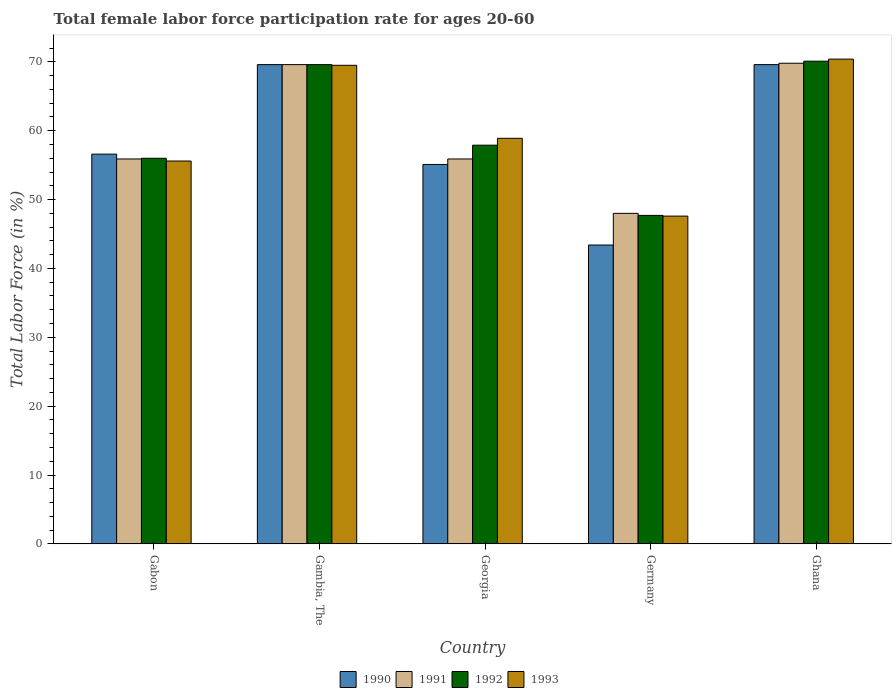How many groups of bars are there?
Provide a short and direct response. 5. Are the number of bars per tick equal to the number of legend labels?
Offer a very short reply. Yes. Are the number of bars on each tick of the X-axis equal?
Provide a succinct answer. Yes. How many bars are there on the 2nd tick from the right?
Keep it short and to the point. 4. What is the label of the 1st group of bars from the left?
Keep it short and to the point. Gabon. What is the female labor force participation rate in 1991 in Georgia?
Provide a short and direct response. 55.9. Across all countries, what is the maximum female labor force participation rate in 1990?
Provide a short and direct response. 69.6. Across all countries, what is the minimum female labor force participation rate in 1991?
Your response must be concise. 48. In which country was the female labor force participation rate in 1993 maximum?
Your answer should be compact. Ghana. In which country was the female labor force participation rate in 1993 minimum?
Offer a very short reply. Germany. What is the total female labor force participation rate in 1993 in the graph?
Offer a terse response. 302. What is the difference between the female labor force participation rate in 1992 in Gabon and that in Germany?
Ensure brevity in your answer.  8.3. What is the difference between the female labor force participation rate in 1993 in Gambia, The and the female labor force participation rate in 1992 in Georgia?
Ensure brevity in your answer.  11.6. What is the average female labor force participation rate in 1990 per country?
Provide a succinct answer. 58.86. What is the difference between the female labor force participation rate of/in 1991 and female labor force participation rate of/in 1993 in Gambia, The?
Your response must be concise. 0.1. What is the ratio of the female labor force participation rate in 1993 in Gambia, The to that in Germany?
Offer a very short reply. 1.46. Is the female labor force participation rate in 1993 in Gambia, The less than that in Ghana?
Give a very brief answer. Yes. Is the difference between the female labor force participation rate in 1991 in Georgia and Ghana greater than the difference between the female labor force participation rate in 1993 in Georgia and Ghana?
Keep it short and to the point. No. What is the difference between the highest and the second highest female labor force participation rate in 1992?
Your response must be concise. -11.7. What is the difference between the highest and the lowest female labor force participation rate in 1992?
Offer a terse response. 22.4. In how many countries, is the female labor force participation rate in 1992 greater than the average female labor force participation rate in 1992 taken over all countries?
Your response must be concise. 2. Is it the case that in every country, the sum of the female labor force participation rate in 1993 and female labor force participation rate in 1990 is greater than the sum of female labor force participation rate in 1991 and female labor force participation rate in 1992?
Ensure brevity in your answer.  No. What does the 2nd bar from the right in Gambia, The represents?
Ensure brevity in your answer.  1992. Is it the case that in every country, the sum of the female labor force participation rate in 1992 and female labor force participation rate in 1991 is greater than the female labor force participation rate in 1993?
Ensure brevity in your answer.  Yes. How many bars are there?
Offer a very short reply. 20. Are all the bars in the graph horizontal?
Your response must be concise. No. What is the difference between two consecutive major ticks on the Y-axis?
Offer a very short reply. 10. Does the graph contain grids?
Give a very brief answer. No. Where does the legend appear in the graph?
Keep it short and to the point. Bottom center. How many legend labels are there?
Offer a terse response. 4. What is the title of the graph?
Ensure brevity in your answer.  Total female labor force participation rate for ages 20-60. Does "1963" appear as one of the legend labels in the graph?
Give a very brief answer. No. What is the label or title of the X-axis?
Provide a short and direct response. Country. What is the label or title of the Y-axis?
Offer a terse response. Total Labor Force (in %). What is the Total Labor Force (in %) in 1990 in Gabon?
Offer a terse response. 56.6. What is the Total Labor Force (in %) in 1991 in Gabon?
Provide a short and direct response. 55.9. What is the Total Labor Force (in %) of 1993 in Gabon?
Give a very brief answer. 55.6. What is the Total Labor Force (in %) of 1990 in Gambia, The?
Offer a terse response. 69.6. What is the Total Labor Force (in %) in 1991 in Gambia, The?
Your response must be concise. 69.6. What is the Total Labor Force (in %) in 1992 in Gambia, The?
Offer a very short reply. 69.6. What is the Total Labor Force (in %) of 1993 in Gambia, The?
Keep it short and to the point. 69.5. What is the Total Labor Force (in %) in 1990 in Georgia?
Your answer should be very brief. 55.1. What is the Total Labor Force (in %) of 1991 in Georgia?
Ensure brevity in your answer.  55.9. What is the Total Labor Force (in %) in 1992 in Georgia?
Ensure brevity in your answer.  57.9. What is the Total Labor Force (in %) of 1993 in Georgia?
Make the answer very short. 58.9. What is the Total Labor Force (in %) in 1990 in Germany?
Your answer should be compact. 43.4. What is the Total Labor Force (in %) of 1992 in Germany?
Offer a terse response. 47.7. What is the Total Labor Force (in %) in 1993 in Germany?
Provide a short and direct response. 47.6. What is the Total Labor Force (in %) in 1990 in Ghana?
Keep it short and to the point. 69.6. What is the Total Labor Force (in %) in 1991 in Ghana?
Make the answer very short. 69.8. What is the Total Labor Force (in %) of 1992 in Ghana?
Ensure brevity in your answer.  70.1. What is the Total Labor Force (in %) of 1993 in Ghana?
Offer a terse response. 70.4. Across all countries, what is the maximum Total Labor Force (in %) in 1990?
Your answer should be compact. 69.6. Across all countries, what is the maximum Total Labor Force (in %) of 1991?
Your response must be concise. 69.8. Across all countries, what is the maximum Total Labor Force (in %) in 1992?
Provide a short and direct response. 70.1. Across all countries, what is the maximum Total Labor Force (in %) in 1993?
Your answer should be compact. 70.4. Across all countries, what is the minimum Total Labor Force (in %) of 1990?
Provide a short and direct response. 43.4. Across all countries, what is the minimum Total Labor Force (in %) in 1992?
Provide a succinct answer. 47.7. Across all countries, what is the minimum Total Labor Force (in %) in 1993?
Offer a terse response. 47.6. What is the total Total Labor Force (in %) of 1990 in the graph?
Your response must be concise. 294.3. What is the total Total Labor Force (in %) in 1991 in the graph?
Your answer should be compact. 299.2. What is the total Total Labor Force (in %) in 1992 in the graph?
Provide a short and direct response. 301.3. What is the total Total Labor Force (in %) in 1993 in the graph?
Your response must be concise. 302. What is the difference between the Total Labor Force (in %) in 1991 in Gabon and that in Gambia, The?
Your answer should be very brief. -13.7. What is the difference between the Total Labor Force (in %) in 1992 in Gabon and that in Gambia, The?
Ensure brevity in your answer.  -13.6. What is the difference between the Total Labor Force (in %) of 1990 in Gabon and that in Georgia?
Your response must be concise. 1.5. What is the difference between the Total Labor Force (in %) of 1993 in Gabon and that in Georgia?
Make the answer very short. -3.3. What is the difference between the Total Labor Force (in %) in 1990 in Gabon and that in Germany?
Your answer should be very brief. 13.2. What is the difference between the Total Labor Force (in %) of 1991 in Gabon and that in Germany?
Your response must be concise. 7.9. What is the difference between the Total Labor Force (in %) of 1992 in Gabon and that in Germany?
Give a very brief answer. 8.3. What is the difference between the Total Labor Force (in %) in 1993 in Gabon and that in Germany?
Ensure brevity in your answer.  8. What is the difference between the Total Labor Force (in %) in 1990 in Gabon and that in Ghana?
Keep it short and to the point. -13. What is the difference between the Total Labor Force (in %) in 1991 in Gabon and that in Ghana?
Give a very brief answer. -13.9. What is the difference between the Total Labor Force (in %) in 1992 in Gabon and that in Ghana?
Make the answer very short. -14.1. What is the difference between the Total Labor Force (in %) in 1993 in Gabon and that in Ghana?
Provide a short and direct response. -14.8. What is the difference between the Total Labor Force (in %) of 1991 in Gambia, The and that in Georgia?
Your response must be concise. 13.7. What is the difference between the Total Labor Force (in %) in 1993 in Gambia, The and that in Georgia?
Your answer should be compact. 10.6. What is the difference between the Total Labor Force (in %) in 1990 in Gambia, The and that in Germany?
Provide a succinct answer. 26.2. What is the difference between the Total Labor Force (in %) in 1991 in Gambia, The and that in Germany?
Ensure brevity in your answer.  21.6. What is the difference between the Total Labor Force (in %) in 1992 in Gambia, The and that in Germany?
Provide a succinct answer. 21.9. What is the difference between the Total Labor Force (in %) in 1993 in Gambia, The and that in Germany?
Make the answer very short. 21.9. What is the difference between the Total Labor Force (in %) of 1991 in Gambia, The and that in Ghana?
Your answer should be very brief. -0.2. What is the difference between the Total Labor Force (in %) in 1992 in Gambia, The and that in Ghana?
Ensure brevity in your answer.  -0.5. What is the difference between the Total Labor Force (in %) of 1993 in Gambia, The and that in Ghana?
Offer a very short reply. -0.9. What is the difference between the Total Labor Force (in %) of 1990 in Georgia and that in Germany?
Offer a terse response. 11.7. What is the difference between the Total Labor Force (in %) of 1992 in Georgia and that in Germany?
Ensure brevity in your answer.  10.2. What is the difference between the Total Labor Force (in %) in 1990 in Germany and that in Ghana?
Provide a succinct answer. -26.2. What is the difference between the Total Labor Force (in %) in 1991 in Germany and that in Ghana?
Your answer should be compact. -21.8. What is the difference between the Total Labor Force (in %) of 1992 in Germany and that in Ghana?
Provide a succinct answer. -22.4. What is the difference between the Total Labor Force (in %) of 1993 in Germany and that in Ghana?
Provide a short and direct response. -22.8. What is the difference between the Total Labor Force (in %) in 1990 in Gabon and the Total Labor Force (in %) in 1993 in Gambia, The?
Your response must be concise. -12.9. What is the difference between the Total Labor Force (in %) in 1991 in Gabon and the Total Labor Force (in %) in 1992 in Gambia, The?
Ensure brevity in your answer.  -13.7. What is the difference between the Total Labor Force (in %) of 1991 in Gabon and the Total Labor Force (in %) of 1993 in Gambia, The?
Offer a terse response. -13.6. What is the difference between the Total Labor Force (in %) in 1992 in Gabon and the Total Labor Force (in %) in 1993 in Gambia, The?
Keep it short and to the point. -13.5. What is the difference between the Total Labor Force (in %) of 1990 in Gabon and the Total Labor Force (in %) of 1991 in Georgia?
Provide a succinct answer. 0.7. What is the difference between the Total Labor Force (in %) of 1990 in Gabon and the Total Labor Force (in %) of 1993 in Georgia?
Keep it short and to the point. -2.3. What is the difference between the Total Labor Force (in %) in 1991 in Gabon and the Total Labor Force (in %) in 1993 in Georgia?
Keep it short and to the point. -3. What is the difference between the Total Labor Force (in %) of 1992 in Gabon and the Total Labor Force (in %) of 1993 in Georgia?
Your answer should be very brief. -2.9. What is the difference between the Total Labor Force (in %) of 1990 in Gabon and the Total Labor Force (in %) of 1991 in Germany?
Keep it short and to the point. 8.6. What is the difference between the Total Labor Force (in %) in 1990 in Gabon and the Total Labor Force (in %) in 1992 in Germany?
Give a very brief answer. 8.9. What is the difference between the Total Labor Force (in %) of 1990 in Gabon and the Total Labor Force (in %) of 1993 in Germany?
Provide a succinct answer. 9. What is the difference between the Total Labor Force (in %) of 1991 in Gabon and the Total Labor Force (in %) of 1992 in Germany?
Offer a very short reply. 8.2. What is the difference between the Total Labor Force (in %) in 1991 in Gabon and the Total Labor Force (in %) in 1993 in Germany?
Provide a succinct answer. 8.3. What is the difference between the Total Labor Force (in %) in 1990 in Gabon and the Total Labor Force (in %) in 1991 in Ghana?
Your response must be concise. -13.2. What is the difference between the Total Labor Force (in %) in 1990 in Gabon and the Total Labor Force (in %) in 1993 in Ghana?
Keep it short and to the point. -13.8. What is the difference between the Total Labor Force (in %) of 1991 in Gabon and the Total Labor Force (in %) of 1993 in Ghana?
Your response must be concise. -14.5. What is the difference between the Total Labor Force (in %) of 1992 in Gabon and the Total Labor Force (in %) of 1993 in Ghana?
Offer a terse response. -14.4. What is the difference between the Total Labor Force (in %) in 1990 in Gambia, The and the Total Labor Force (in %) in 1991 in Georgia?
Offer a terse response. 13.7. What is the difference between the Total Labor Force (in %) of 1990 in Gambia, The and the Total Labor Force (in %) of 1993 in Georgia?
Make the answer very short. 10.7. What is the difference between the Total Labor Force (in %) of 1991 in Gambia, The and the Total Labor Force (in %) of 1992 in Georgia?
Provide a short and direct response. 11.7. What is the difference between the Total Labor Force (in %) in 1991 in Gambia, The and the Total Labor Force (in %) in 1993 in Georgia?
Give a very brief answer. 10.7. What is the difference between the Total Labor Force (in %) of 1990 in Gambia, The and the Total Labor Force (in %) of 1991 in Germany?
Keep it short and to the point. 21.6. What is the difference between the Total Labor Force (in %) in 1990 in Gambia, The and the Total Labor Force (in %) in 1992 in Germany?
Your answer should be very brief. 21.9. What is the difference between the Total Labor Force (in %) in 1990 in Gambia, The and the Total Labor Force (in %) in 1993 in Germany?
Provide a short and direct response. 22. What is the difference between the Total Labor Force (in %) in 1991 in Gambia, The and the Total Labor Force (in %) in 1992 in Germany?
Ensure brevity in your answer.  21.9. What is the difference between the Total Labor Force (in %) of 1991 in Gambia, The and the Total Labor Force (in %) of 1993 in Germany?
Your answer should be compact. 22. What is the difference between the Total Labor Force (in %) in 1990 in Gambia, The and the Total Labor Force (in %) in 1993 in Ghana?
Give a very brief answer. -0.8. What is the difference between the Total Labor Force (in %) of 1991 in Gambia, The and the Total Labor Force (in %) of 1993 in Ghana?
Provide a succinct answer. -0.8. What is the difference between the Total Labor Force (in %) in 1992 in Gambia, The and the Total Labor Force (in %) in 1993 in Ghana?
Provide a short and direct response. -0.8. What is the difference between the Total Labor Force (in %) in 1990 in Georgia and the Total Labor Force (in %) in 1991 in Germany?
Give a very brief answer. 7.1. What is the difference between the Total Labor Force (in %) in 1990 in Georgia and the Total Labor Force (in %) in 1992 in Germany?
Provide a short and direct response. 7.4. What is the difference between the Total Labor Force (in %) in 1991 in Georgia and the Total Labor Force (in %) in 1993 in Germany?
Offer a terse response. 8.3. What is the difference between the Total Labor Force (in %) of 1990 in Georgia and the Total Labor Force (in %) of 1991 in Ghana?
Your response must be concise. -14.7. What is the difference between the Total Labor Force (in %) of 1990 in Georgia and the Total Labor Force (in %) of 1992 in Ghana?
Your response must be concise. -15. What is the difference between the Total Labor Force (in %) of 1990 in Georgia and the Total Labor Force (in %) of 1993 in Ghana?
Make the answer very short. -15.3. What is the difference between the Total Labor Force (in %) in 1990 in Germany and the Total Labor Force (in %) in 1991 in Ghana?
Keep it short and to the point. -26.4. What is the difference between the Total Labor Force (in %) in 1990 in Germany and the Total Labor Force (in %) in 1992 in Ghana?
Offer a very short reply. -26.7. What is the difference between the Total Labor Force (in %) of 1991 in Germany and the Total Labor Force (in %) of 1992 in Ghana?
Ensure brevity in your answer.  -22.1. What is the difference between the Total Labor Force (in %) in 1991 in Germany and the Total Labor Force (in %) in 1993 in Ghana?
Give a very brief answer. -22.4. What is the difference between the Total Labor Force (in %) of 1992 in Germany and the Total Labor Force (in %) of 1993 in Ghana?
Provide a short and direct response. -22.7. What is the average Total Labor Force (in %) of 1990 per country?
Offer a very short reply. 58.86. What is the average Total Labor Force (in %) of 1991 per country?
Provide a short and direct response. 59.84. What is the average Total Labor Force (in %) of 1992 per country?
Your response must be concise. 60.26. What is the average Total Labor Force (in %) of 1993 per country?
Offer a terse response. 60.4. What is the difference between the Total Labor Force (in %) in 1990 and Total Labor Force (in %) in 1992 in Gabon?
Your answer should be very brief. 0.6. What is the difference between the Total Labor Force (in %) of 1991 and Total Labor Force (in %) of 1992 in Gabon?
Offer a terse response. -0.1. What is the difference between the Total Labor Force (in %) of 1992 and Total Labor Force (in %) of 1993 in Gabon?
Keep it short and to the point. 0.4. What is the difference between the Total Labor Force (in %) in 1990 and Total Labor Force (in %) in 1991 in Gambia, The?
Provide a succinct answer. 0. What is the difference between the Total Labor Force (in %) of 1990 and Total Labor Force (in %) of 1993 in Gambia, The?
Offer a terse response. 0.1. What is the difference between the Total Labor Force (in %) of 1992 and Total Labor Force (in %) of 1993 in Gambia, The?
Ensure brevity in your answer.  0.1. What is the difference between the Total Labor Force (in %) in 1991 and Total Labor Force (in %) in 1993 in Georgia?
Your answer should be very brief. -3. What is the difference between the Total Labor Force (in %) in 1992 and Total Labor Force (in %) in 1993 in Georgia?
Ensure brevity in your answer.  -1. What is the difference between the Total Labor Force (in %) in 1990 and Total Labor Force (in %) in 1991 in Germany?
Make the answer very short. -4.6. What is the difference between the Total Labor Force (in %) of 1991 and Total Labor Force (in %) of 1993 in Germany?
Offer a terse response. 0.4. What is the difference between the Total Labor Force (in %) of 1990 and Total Labor Force (in %) of 1992 in Ghana?
Your response must be concise. -0.5. What is the difference between the Total Labor Force (in %) in 1990 and Total Labor Force (in %) in 1993 in Ghana?
Your answer should be very brief. -0.8. What is the difference between the Total Labor Force (in %) of 1991 and Total Labor Force (in %) of 1992 in Ghana?
Offer a very short reply. -0.3. What is the difference between the Total Labor Force (in %) in 1992 and Total Labor Force (in %) in 1993 in Ghana?
Keep it short and to the point. -0.3. What is the ratio of the Total Labor Force (in %) in 1990 in Gabon to that in Gambia, The?
Your answer should be very brief. 0.81. What is the ratio of the Total Labor Force (in %) of 1991 in Gabon to that in Gambia, The?
Provide a short and direct response. 0.8. What is the ratio of the Total Labor Force (in %) in 1992 in Gabon to that in Gambia, The?
Provide a succinct answer. 0.8. What is the ratio of the Total Labor Force (in %) of 1990 in Gabon to that in Georgia?
Offer a terse response. 1.03. What is the ratio of the Total Labor Force (in %) in 1991 in Gabon to that in Georgia?
Offer a very short reply. 1. What is the ratio of the Total Labor Force (in %) in 1992 in Gabon to that in Georgia?
Your answer should be compact. 0.97. What is the ratio of the Total Labor Force (in %) in 1993 in Gabon to that in Georgia?
Keep it short and to the point. 0.94. What is the ratio of the Total Labor Force (in %) in 1990 in Gabon to that in Germany?
Your answer should be very brief. 1.3. What is the ratio of the Total Labor Force (in %) of 1991 in Gabon to that in Germany?
Make the answer very short. 1.16. What is the ratio of the Total Labor Force (in %) in 1992 in Gabon to that in Germany?
Offer a very short reply. 1.17. What is the ratio of the Total Labor Force (in %) of 1993 in Gabon to that in Germany?
Offer a terse response. 1.17. What is the ratio of the Total Labor Force (in %) of 1990 in Gabon to that in Ghana?
Offer a very short reply. 0.81. What is the ratio of the Total Labor Force (in %) in 1991 in Gabon to that in Ghana?
Offer a terse response. 0.8. What is the ratio of the Total Labor Force (in %) of 1992 in Gabon to that in Ghana?
Provide a succinct answer. 0.8. What is the ratio of the Total Labor Force (in %) of 1993 in Gabon to that in Ghana?
Give a very brief answer. 0.79. What is the ratio of the Total Labor Force (in %) in 1990 in Gambia, The to that in Georgia?
Your answer should be very brief. 1.26. What is the ratio of the Total Labor Force (in %) in 1991 in Gambia, The to that in Georgia?
Keep it short and to the point. 1.25. What is the ratio of the Total Labor Force (in %) of 1992 in Gambia, The to that in Georgia?
Provide a succinct answer. 1.2. What is the ratio of the Total Labor Force (in %) of 1993 in Gambia, The to that in Georgia?
Offer a terse response. 1.18. What is the ratio of the Total Labor Force (in %) of 1990 in Gambia, The to that in Germany?
Your answer should be very brief. 1.6. What is the ratio of the Total Labor Force (in %) in 1991 in Gambia, The to that in Germany?
Your answer should be compact. 1.45. What is the ratio of the Total Labor Force (in %) of 1992 in Gambia, The to that in Germany?
Your response must be concise. 1.46. What is the ratio of the Total Labor Force (in %) in 1993 in Gambia, The to that in Germany?
Make the answer very short. 1.46. What is the ratio of the Total Labor Force (in %) of 1991 in Gambia, The to that in Ghana?
Make the answer very short. 1. What is the ratio of the Total Labor Force (in %) of 1993 in Gambia, The to that in Ghana?
Offer a very short reply. 0.99. What is the ratio of the Total Labor Force (in %) in 1990 in Georgia to that in Germany?
Provide a short and direct response. 1.27. What is the ratio of the Total Labor Force (in %) in 1991 in Georgia to that in Germany?
Your response must be concise. 1.16. What is the ratio of the Total Labor Force (in %) in 1992 in Georgia to that in Germany?
Give a very brief answer. 1.21. What is the ratio of the Total Labor Force (in %) of 1993 in Georgia to that in Germany?
Keep it short and to the point. 1.24. What is the ratio of the Total Labor Force (in %) in 1990 in Georgia to that in Ghana?
Give a very brief answer. 0.79. What is the ratio of the Total Labor Force (in %) in 1991 in Georgia to that in Ghana?
Make the answer very short. 0.8. What is the ratio of the Total Labor Force (in %) in 1992 in Georgia to that in Ghana?
Keep it short and to the point. 0.83. What is the ratio of the Total Labor Force (in %) in 1993 in Georgia to that in Ghana?
Your answer should be compact. 0.84. What is the ratio of the Total Labor Force (in %) in 1990 in Germany to that in Ghana?
Your answer should be compact. 0.62. What is the ratio of the Total Labor Force (in %) in 1991 in Germany to that in Ghana?
Make the answer very short. 0.69. What is the ratio of the Total Labor Force (in %) in 1992 in Germany to that in Ghana?
Offer a terse response. 0.68. What is the ratio of the Total Labor Force (in %) of 1993 in Germany to that in Ghana?
Your answer should be compact. 0.68. What is the difference between the highest and the second highest Total Labor Force (in %) of 1990?
Give a very brief answer. 0. What is the difference between the highest and the second highest Total Labor Force (in %) of 1991?
Offer a terse response. 0.2. What is the difference between the highest and the second highest Total Labor Force (in %) in 1992?
Give a very brief answer. 0.5. What is the difference between the highest and the second highest Total Labor Force (in %) of 1993?
Provide a succinct answer. 0.9. What is the difference between the highest and the lowest Total Labor Force (in %) in 1990?
Offer a terse response. 26.2. What is the difference between the highest and the lowest Total Labor Force (in %) in 1991?
Provide a succinct answer. 21.8. What is the difference between the highest and the lowest Total Labor Force (in %) in 1992?
Offer a very short reply. 22.4. What is the difference between the highest and the lowest Total Labor Force (in %) of 1993?
Provide a succinct answer. 22.8. 